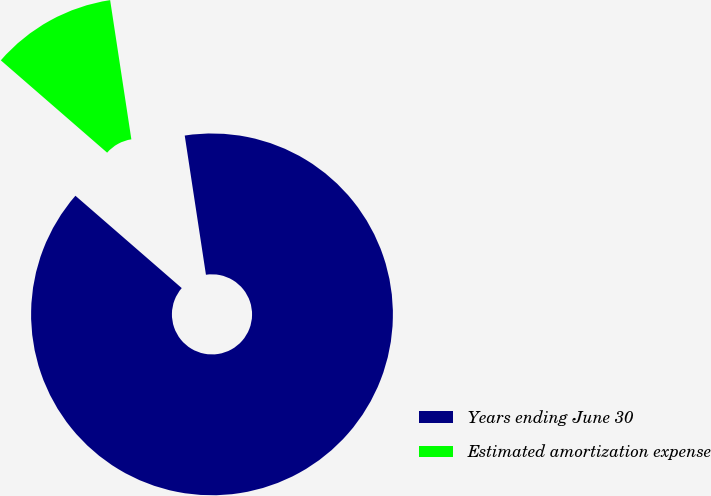Convert chart to OTSL. <chart><loc_0><loc_0><loc_500><loc_500><pie_chart><fcel>Years ending June 30<fcel>Estimated amortization expense<nl><fcel>88.79%<fcel>11.21%<nl></chart> 